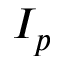<formula> <loc_0><loc_0><loc_500><loc_500>I _ { p }</formula> 